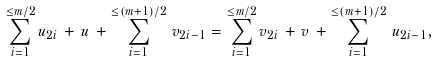<formula> <loc_0><loc_0><loc_500><loc_500>\sum _ { i = 1 } ^ { \leq m / 2 } u _ { 2 i } \, + \, u \, + \sum _ { i = 1 } ^ { \leq ( m + 1 ) / 2 } \, v _ { 2 i - 1 } = \sum _ { i = 1 } ^ { \leq m / 2 } v _ { 2 i } \, + \, v \, + \sum _ { i = 1 } ^ { \leq ( m + 1 ) / 2 } \, u _ { 2 i - 1 } ,</formula> 